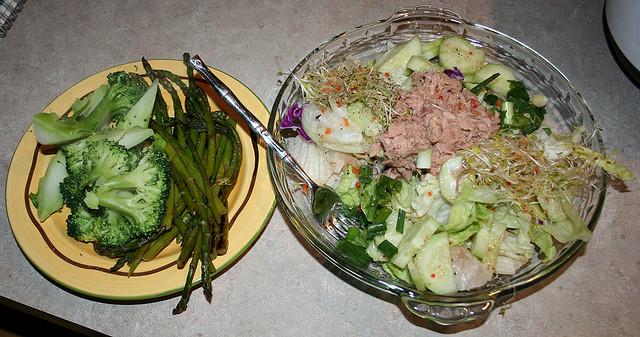Is there asparagus in this picture?
Write a very short answer. Yes. Is there tuna salad on one of the plates?
Answer briefly. Yes. Is there a notebook in the picture?
Write a very short answer. No. 